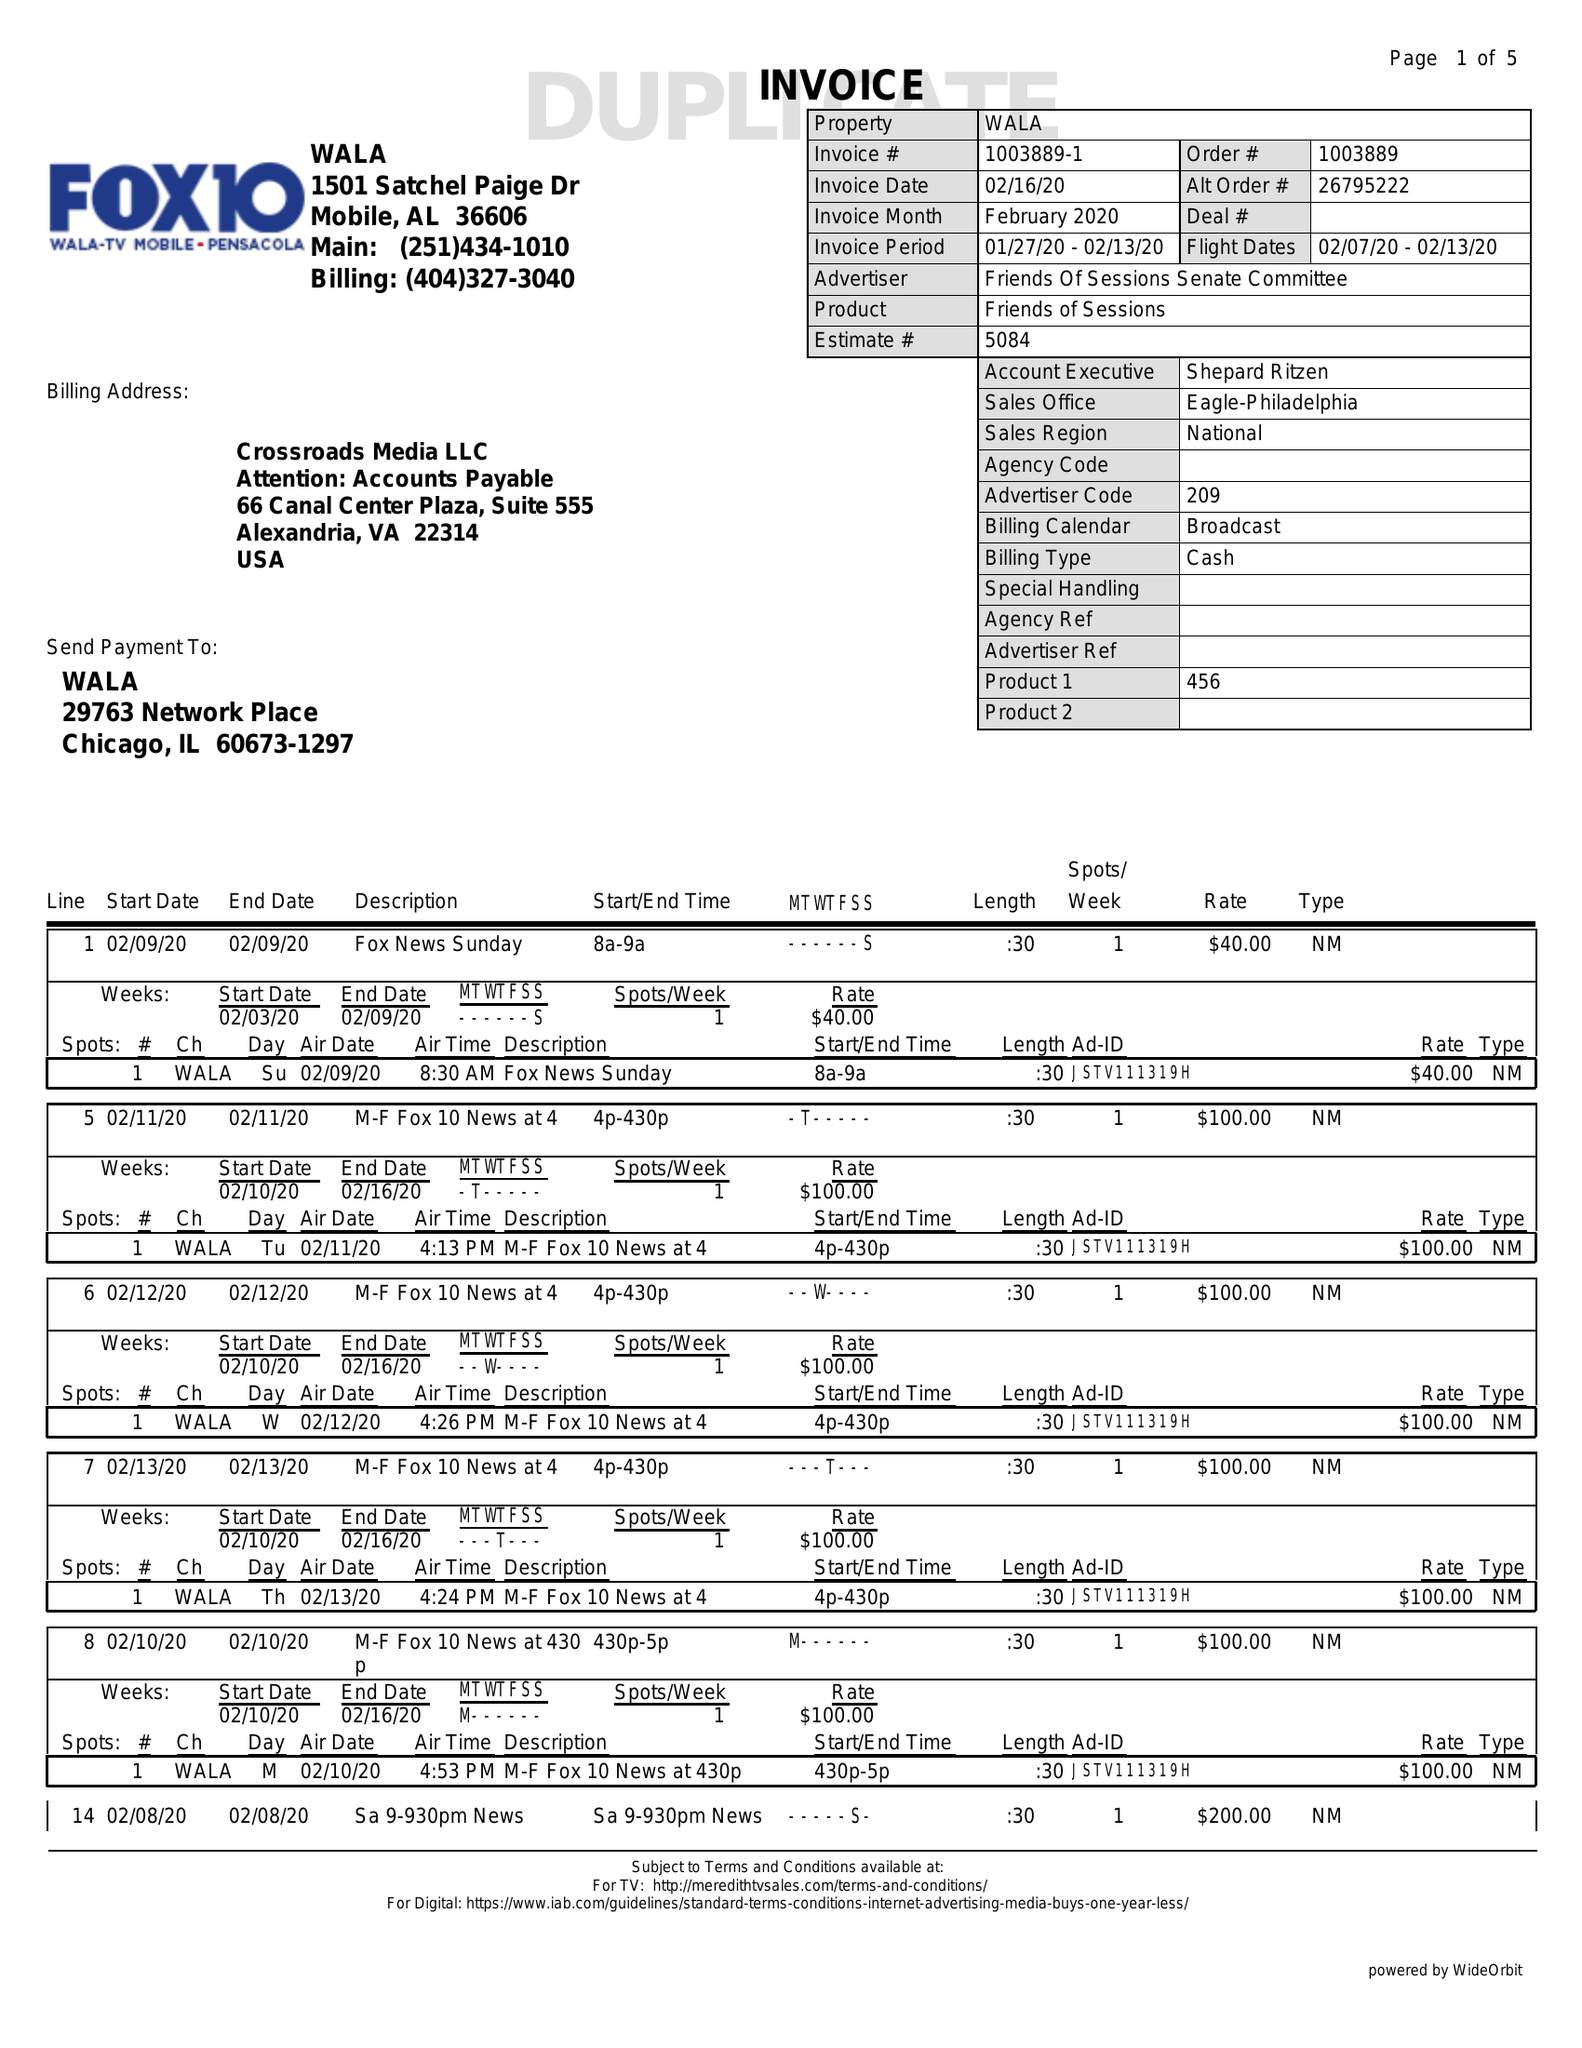What is the value for the flight_to?
Answer the question using a single word or phrase. 02/13/20 